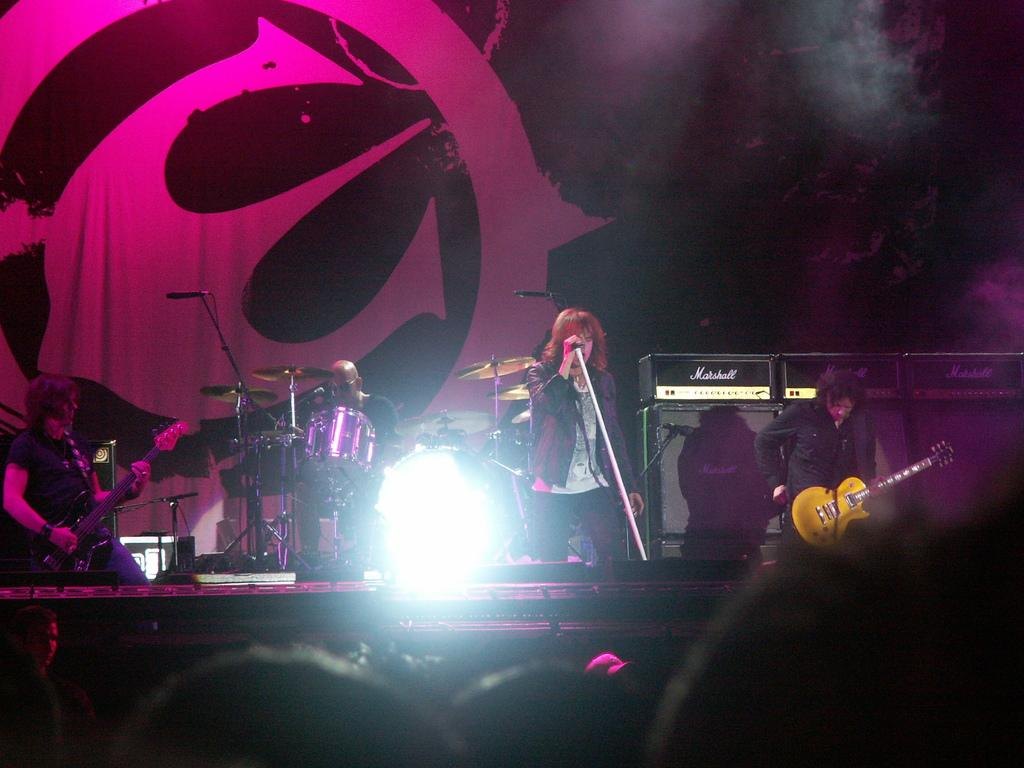How many people are in the image? There are four persons in the image. What are two of the persons holding? Two of the persons are holding guitars. What is the third person holding? One person is holding a microphone. What is the fourth person doing? One person is playing drums. What type of religious ceremony is taking place in the image? There is no indication of a religious ceremony in the image; the focus is on the musical instruments and microphone. How many spiders can be seen crawling on the drum set in the image? There are no spiders present in the image; the focus is on the people and their instruments. 